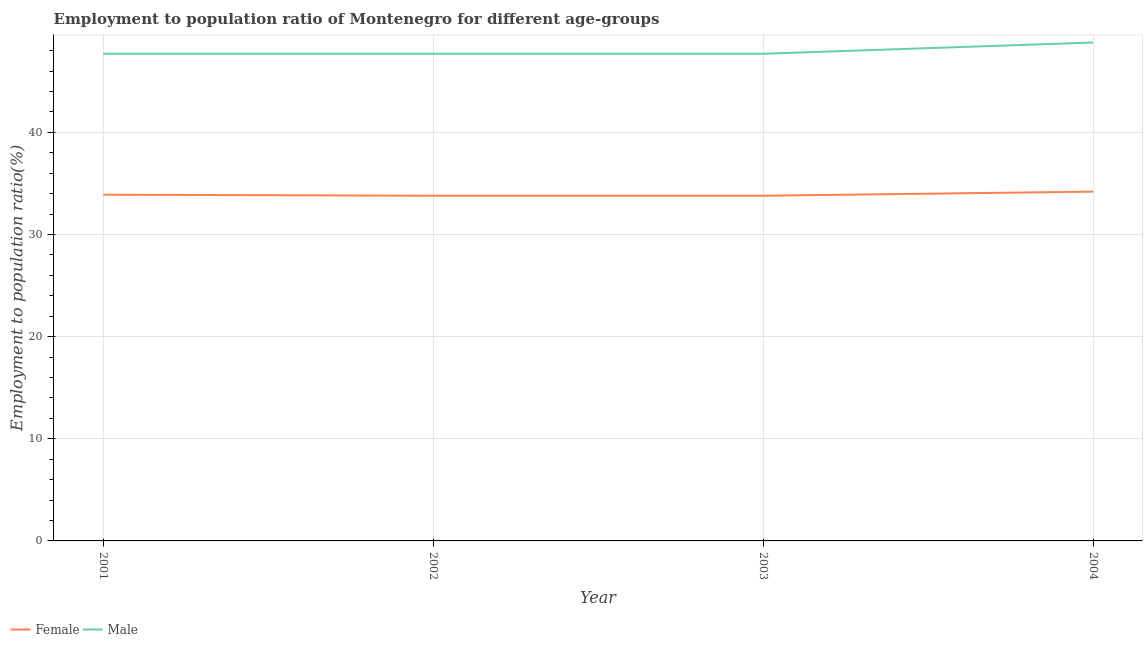How many different coloured lines are there?
Your answer should be very brief. 2. Does the line corresponding to employment to population ratio(male) intersect with the line corresponding to employment to population ratio(female)?
Your response must be concise. No. What is the employment to population ratio(male) in 2004?
Offer a very short reply. 48.8. Across all years, what is the maximum employment to population ratio(female)?
Your answer should be compact. 34.2. Across all years, what is the minimum employment to population ratio(male)?
Your answer should be very brief. 47.7. In which year was the employment to population ratio(female) maximum?
Make the answer very short. 2004. In which year was the employment to population ratio(female) minimum?
Your answer should be compact. 2002. What is the total employment to population ratio(female) in the graph?
Offer a terse response. 135.7. What is the average employment to population ratio(female) per year?
Provide a short and direct response. 33.93. In the year 2002, what is the difference between the employment to population ratio(male) and employment to population ratio(female)?
Ensure brevity in your answer.  13.9. What is the ratio of the employment to population ratio(female) in 2003 to that in 2004?
Your response must be concise. 0.99. What is the difference between the highest and the second highest employment to population ratio(female)?
Offer a terse response. 0.3. What is the difference between the highest and the lowest employment to population ratio(male)?
Provide a short and direct response. 1.1. Is the employment to population ratio(female) strictly greater than the employment to population ratio(male) over the years?
Ensure brevity in your answer.  No. Is the employment to population ratio(female) strictly less than the employment to population ratio(male) over the years?
Your response must be concise. Yes. How many lines are there?
Your response must be concise. 2. What is the difference between two consecutive major ticks on the Y-axis?
Keep it short and to the point. 10. Does the graph contain any zero values?
Keep it short and to the point. No. How many legend labels are there?
Your answer should be compact. 2. How are the legend labels stacked?
Make the answer very short. Horizontal. What is the title of the graph?
Your answer should be very brief. Employment to population ratio of Montenegro for different age-groups. Does "Female population" appear as one of the legend labels in the graph?
Your answer should be very brief. No. What is the label or title of the X-axis?
Give a very brief answer. Year. What is the label or title of the Y-axis?
Make the answer very short. Employment to population ratio(%). What is the Employment to population ratio(%) of Female in 2001?
Your answer should be compact. 33.9. What is the Employment to population ratio(%) of Male in 2001?
Offer a very short reply. 47.7. What is the Employment to population ratio(%) of Female in 2002?
Your answer should be compact. 33.8. What is the Employment to population ratio(%) in Male in 2002?
Make the answer very short. 47.7. What is the Employment to population ratio(%) of Female in 2003?
Give a very brief answer. 33.8. What is the Employment to population ratio(%) of Male in 2003?
Your answer should be very brief. 47.7. What is the Employment to population ratio(%) in Female in 2004?
Ensure brevity in your answer.  34.2. What is the Employment to population ratio(%) of Male in 2004?
Make the answer very short. 48.8. Across all years, what is the maximum Employment to population ratio(%) in Female?
Provide a short and direct response. 34.2. Across all years, what is the maximum Employment to population ratio(%) in Male?
Keep it short and to the point. 48.8. Across all years, what is the minimum Employment to population ratio(%) in Female?
Your response must be concise. 33.8. Across all years, what is the minimum Employment to population ratio(%) in Male?
Make the answer very short. 47.7. What is the total Employment to population ratio(%) of Female in the graph?
Ensure brevity in your answer.  135.7. What is the total Employment to population ratio(%) of Male in the graph?
Ensure brevity in your answer.  191.9. What is the difference between the Employment to population ratio(%) of Female in 2001 and that in 2002?
Give a very brief answer. 0.1. What is the difference between the Employment to population ratio(%) in Male in 2001 and that in 2002?
Keep it short and to the point. 0. What is the difference between the Employment to population ratio(%) of Female in 2001 and that in 2003?
Keep it short and to the point. 0.1. What is the difference between the Employment to population ratio(%) in Male in 2001 and that in 2004?
Your answer should be compact. -1.1. What is the difference between the Employment to population ratio(%) of Female in 2002 and that in 2003?
Offer a very short reply. 0. What is the difference between the Employment to population ratio(%) in Male in 2002 and that in 2003?
Provide a short and direct response. 0. What is the difference between the Employment to population ratio(%) of Female in 2002 and that in 2004?
Provide a succinct answer. -0.4. What is the difference between the Employment to population ratio(%) in Male in 2003 and that in 2004?
Your answer should be very brief. -1.1. What is the difference between the Employment to population ratio(%) in Female in 2001 and the Employment to population ratio(%) in Male in 2003?
Offer a very short reply. -13.8. What is the difference between the Employment to population ratio(%) of Female in 2001 and the Employment to population ratio(%) of Male in 2004?
Make the answer very short. -14.9. What is the difference between the Employment to population ratio(%) of Female in 2003 and the Employment to population ratio(%) of Male in 2004?
Your answer should be compact. -15. What is the average Employment to population ratio(%) in Female per year?
Keep it short and to the point. 33.92. What is the average Employment to population ratio(%) of Male per year?
Provide a short and direct response. 47.98. In the year 2001, what is the difference between the Employment to population ratio(%) in Female and Employment to population ratio(%) in Male?
Give a very brief answer. -13.8. In the year 2002, what is the difference between the Employment to population ratio(%) of Female and Employment to population ratio(%) of Male?
Your answer should be very brief. -13.9. In the year 2003, what is the difference between the Employment to population ratio(%) in Female and Employment to population ratio(%) in Male?
Keep it short and to the point. -13.9. In the year 2004, what is the difference between the Employment to population ratio(%) of Female and Employment to population ratio(%) of Male?
Ensure brevity in your answer.  -14.6. What is the ratio of the Employment to population ratio(%) in Female in 2001 to that in 2002?
Offer a terse response. 1. What is the ratio of the Employment to population ratio(%) of Male in 2001 to that in 2002?
Provide a short and direct response. 1. What is the ratio of the Employment to population ratio(%) in Female in 2001 to that in 2003?
Provide a short and direct response. 1. What is the ratio of the Employment to population ratio(%) of Male in 2001 to that in 2003?
Offer a very short reply. 1. What is the ratio of the Employment to population ratio(%) in Female in 2001 to that in 2004?
Your answer should be compact. 0.99. What is the ratio of the Employment to population ratio(%) in Male in 2001 to that in 2004?
Make the answer very short. 0.98. What is the ratio of the Employment to population ratio(%) of Female in 2002 to that in 2004?
Your answer should be very brief. 0.99. What is the ratio of the Employment to population ratio(%) in Male in 2002 to that in 2004?
Ensure brevity in your answer.  0.98. What is the ratio of the Employment to population ratio(%) of Female in 2003 to that in 2004?
Give a very brief answer. 0.99. What is the ratio of the Employment to population ratio(%) of Male in 2003 to that in 2004?
Give a very brief answer. 0.98. What is the difference between the highest and the second highest Employment to population ratio(%) of Male?
Your answer should be compact. 1.1. What is the difference between the highest and the lowest Employment to population ratio(%) of Female?
Offer a terse response. 0.4. What is the difference between the highest and the lowest Employment to population ratio(%) in Male?
Provide a succinct answer. 1.1. 